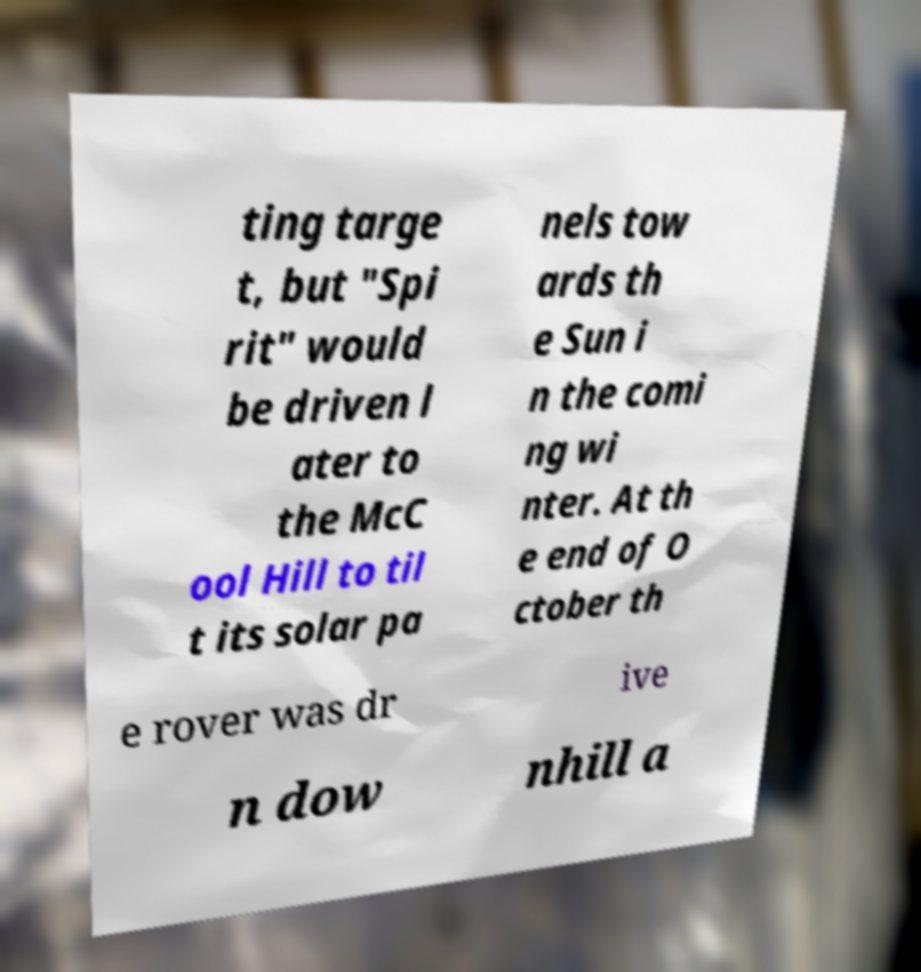There's text embedded in this image that I need extracted. Can you transcribe it verbatim? ting targe t, but "Spi rit" would be driven l ater to the McC ool Hill to til t its solar pa nels tow ards th e Sun i n the comi ng wi nter. At th e end of O ctober th e rover was dr ive n dow nhill a 